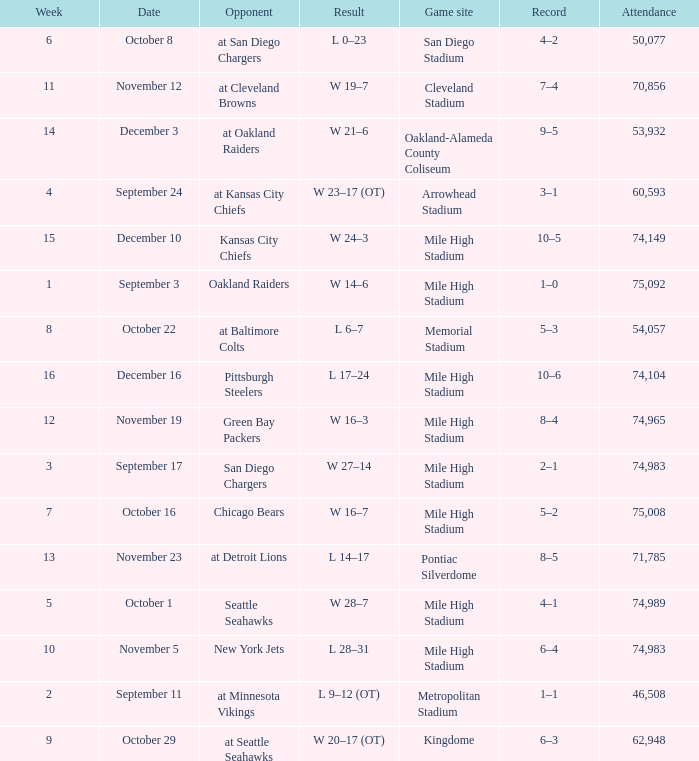When was the outcome recorded as 28-7? October 1. 